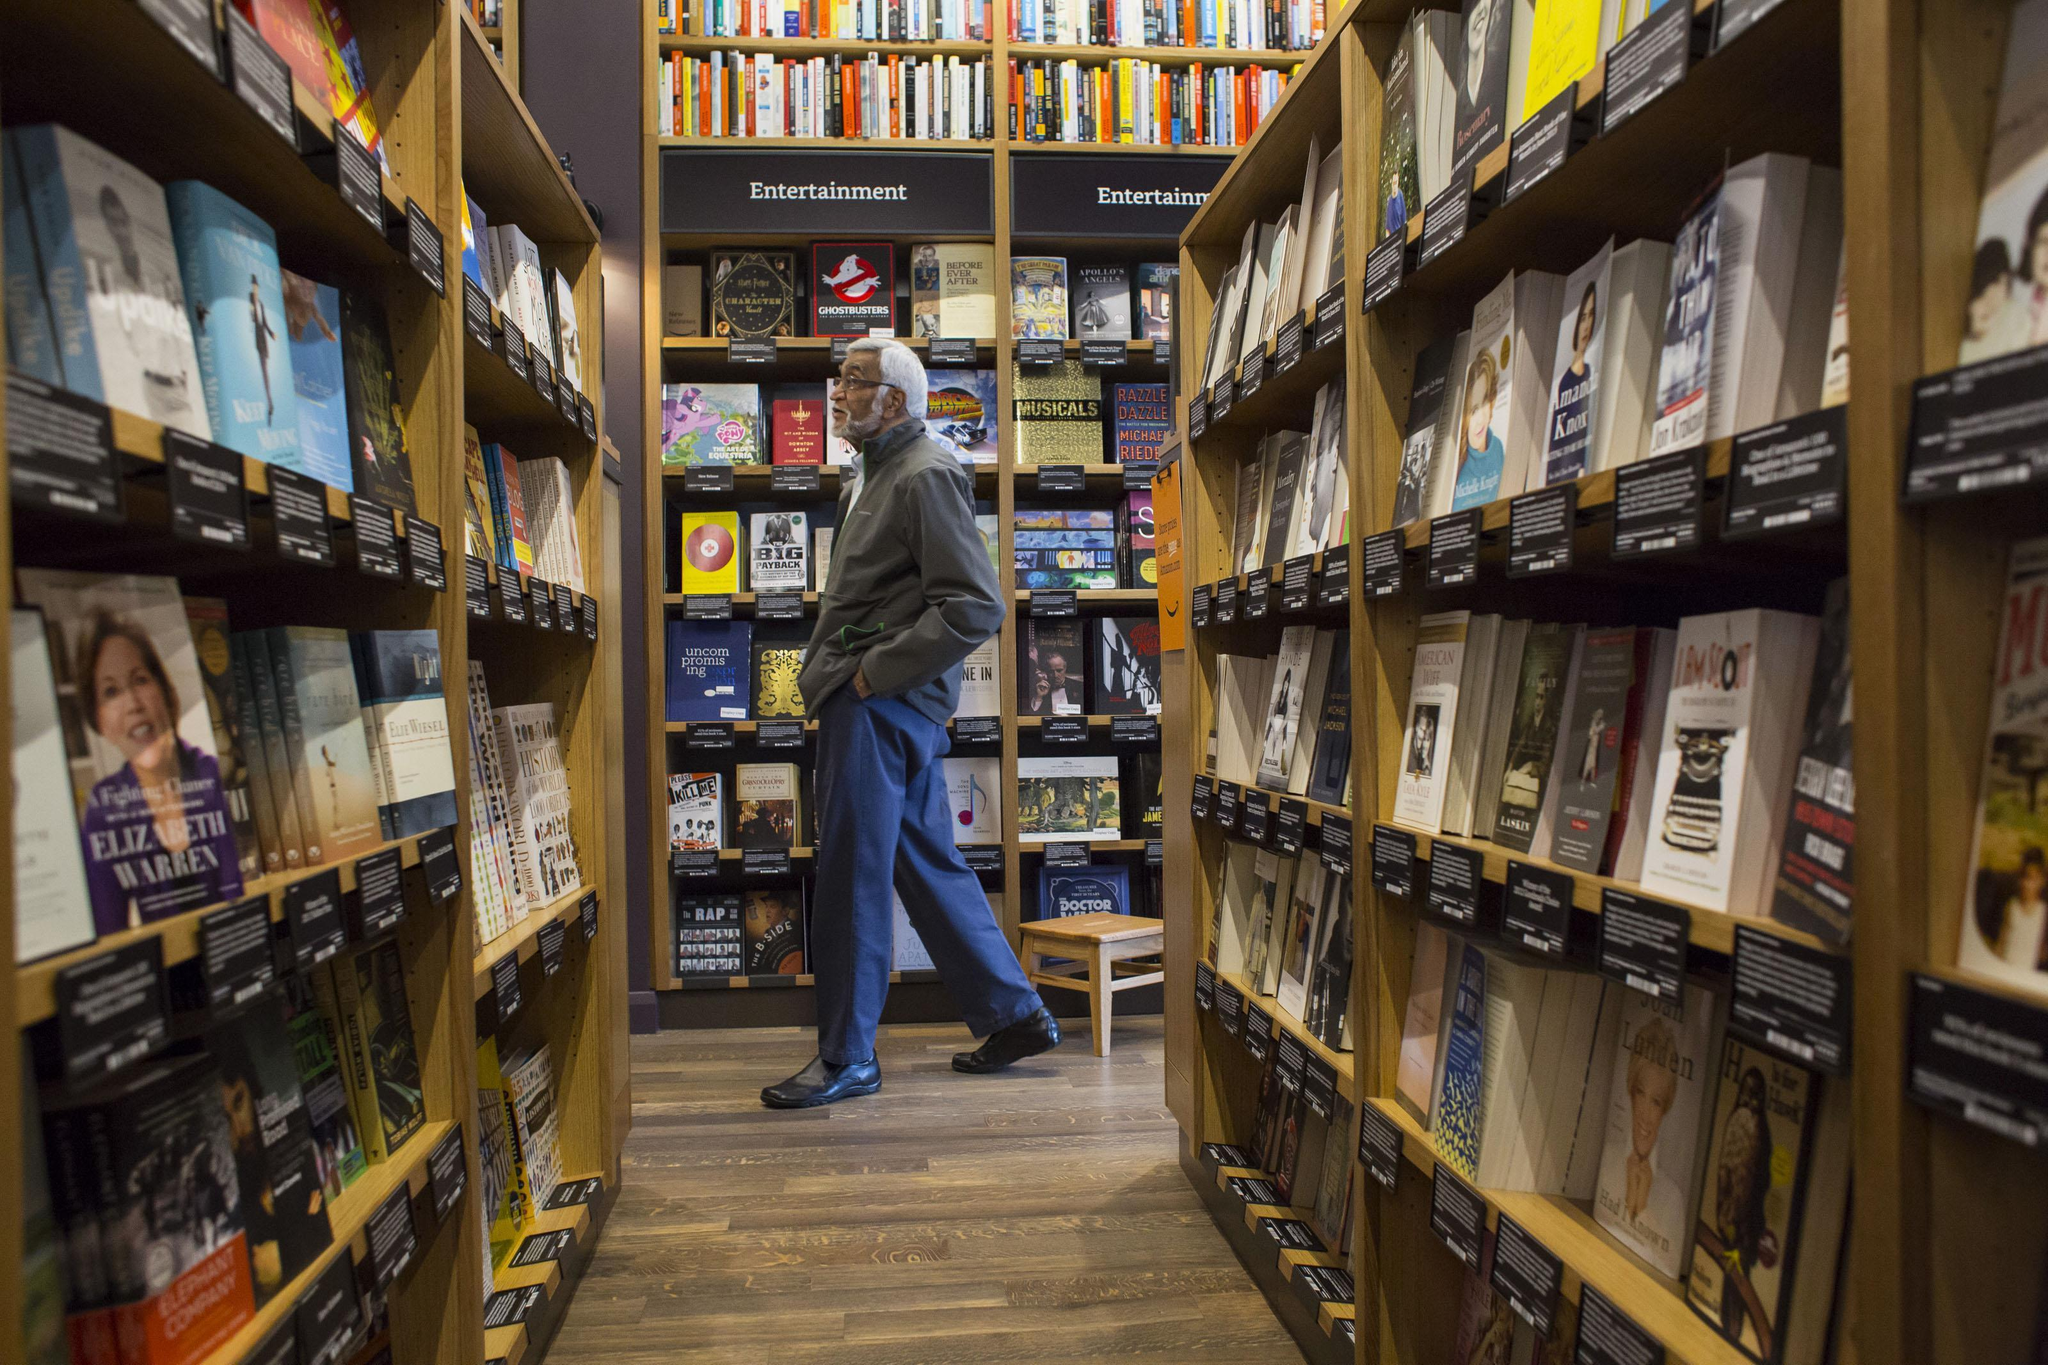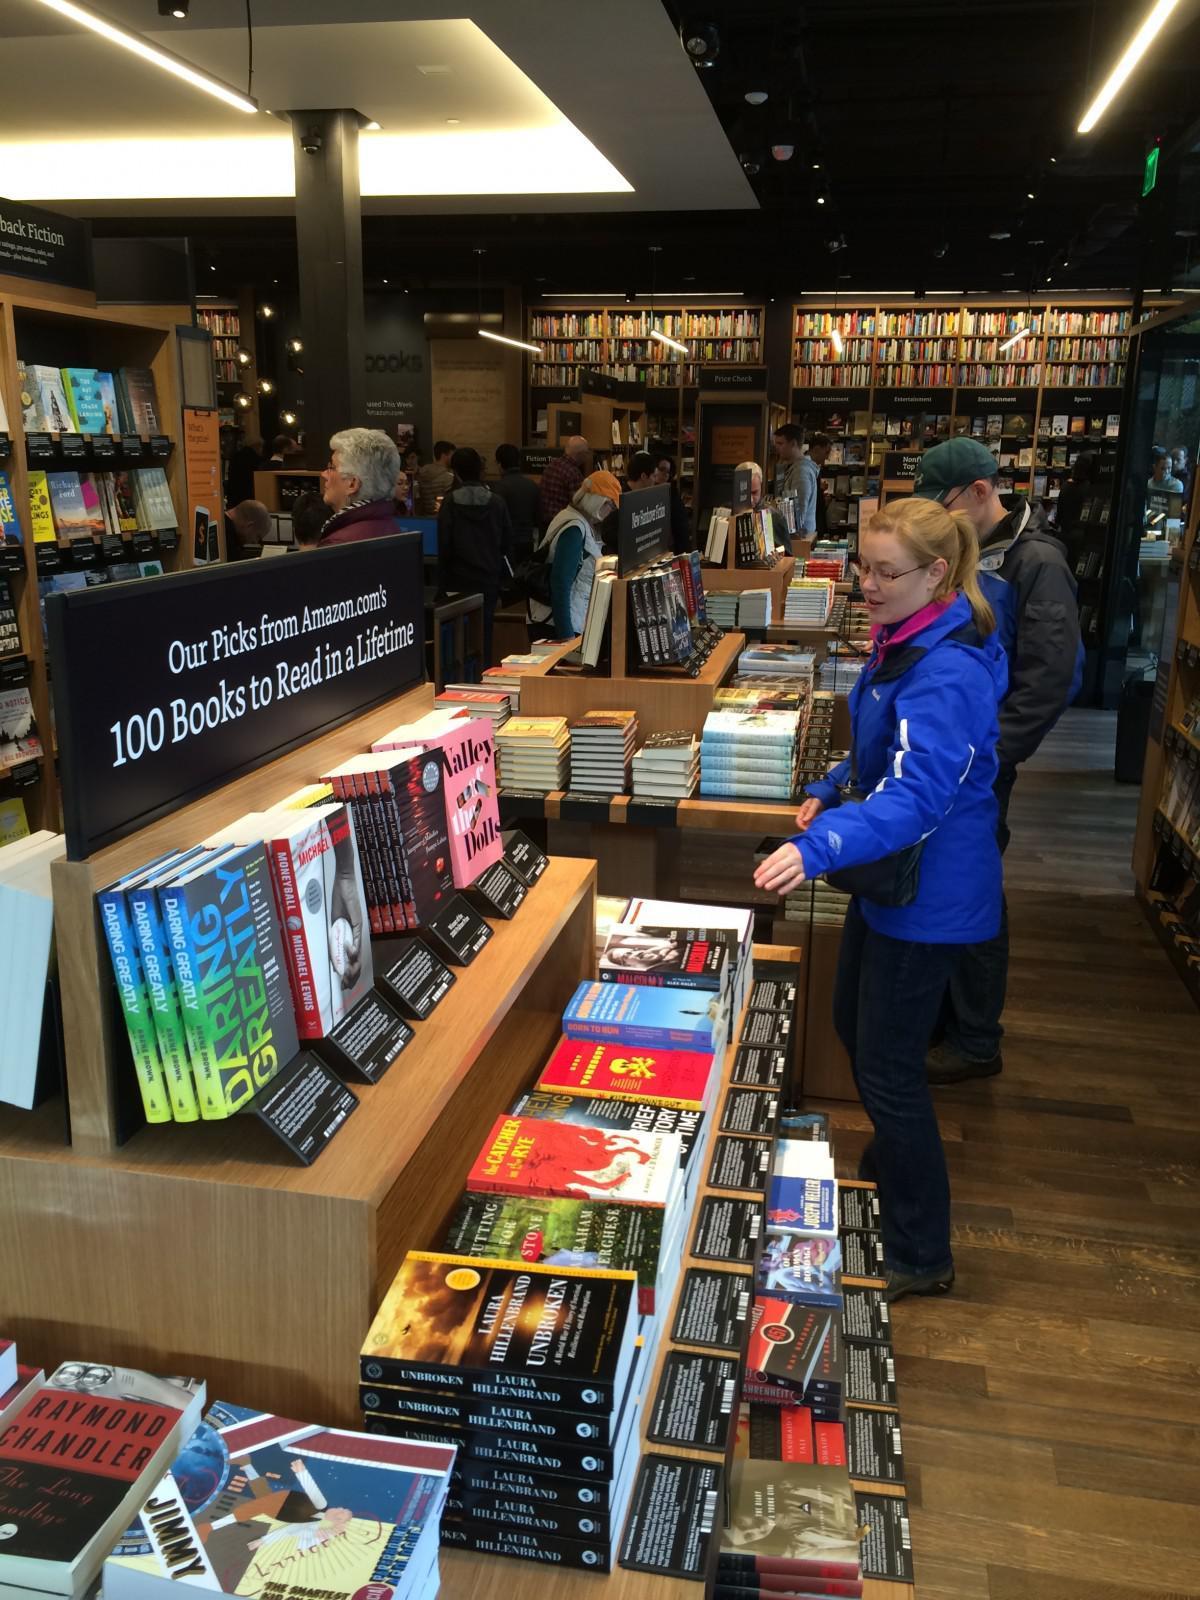The first image is the image on the left, the second image is the image on the right. Examine the images to the left and right. Is the description "the left image has 2 cash registers" accurate? Answer yes or no. No. The first image is the image on the left, the second image is the image on the right. Assess this claim about the two images: "One image shows the front entrance of an Amazon books store.". Correct or not? Answer yes or no. No. 